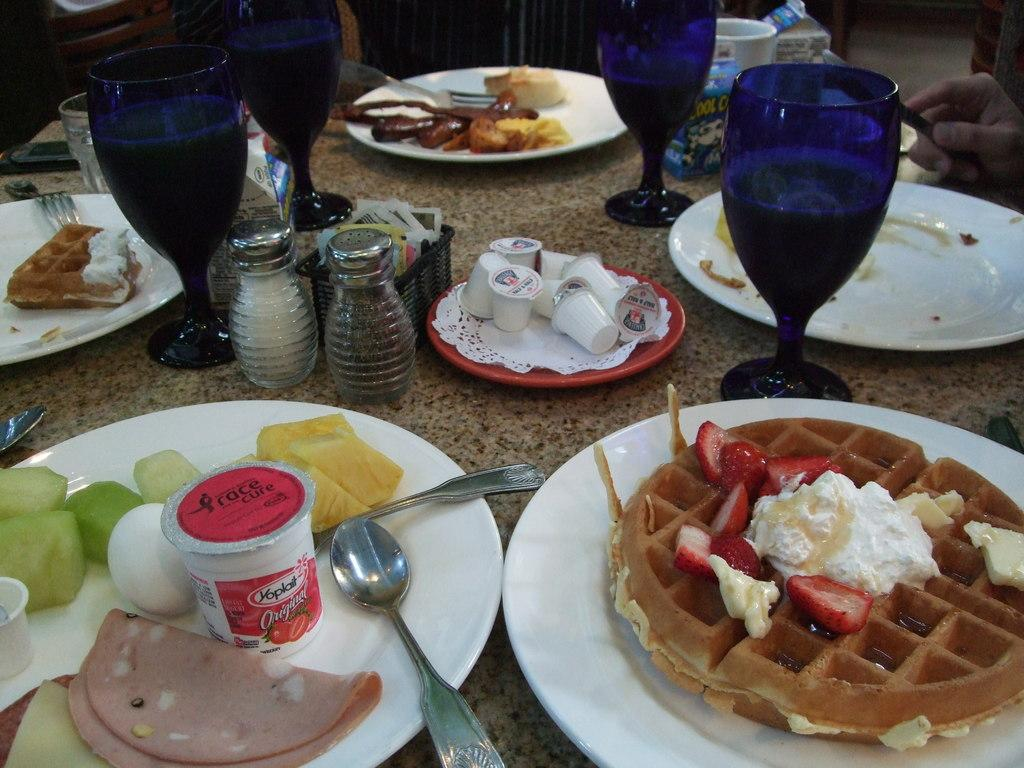What types of food items can be seen in the image? The food items in the image are in white, green, cream, and red colors. How are the food items arranged in the image? The food items are on plates in the image. What else can be seen on the table besides the food items? There are glasses and other objects on the table in the image. How long does it take for the hall to be cleaned in the image? There is no hall present in the image, so it is not possible to determine how long it takes to clean it. 